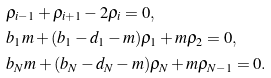Convert formula to latex. <formula><loc_0><loc_0><loc_500><loc_500>& \rho _ { i - 1 } + \rho _ { i + 1 } - 2 \rho _ { i } = 0 , \\ & b _ { 1 } m + ( b _ { 1 } - d _ { 1 } - m ) \rho _ { 1 } + m \rho _ { 2 } = 0 , \\ & b _ { N } m + ( b _ { N } - d _ { N } - m ) \rho _ { N } + m \rho _ { N - 1 } = 0 .</formula> 